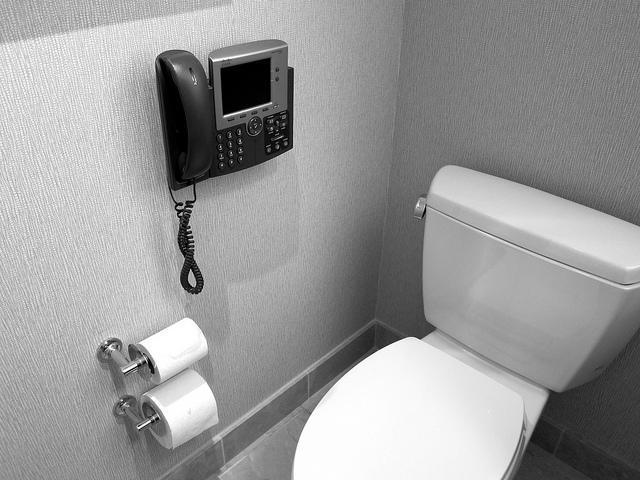How many toilet paper rolls?
Give a very brief answer. 2. 